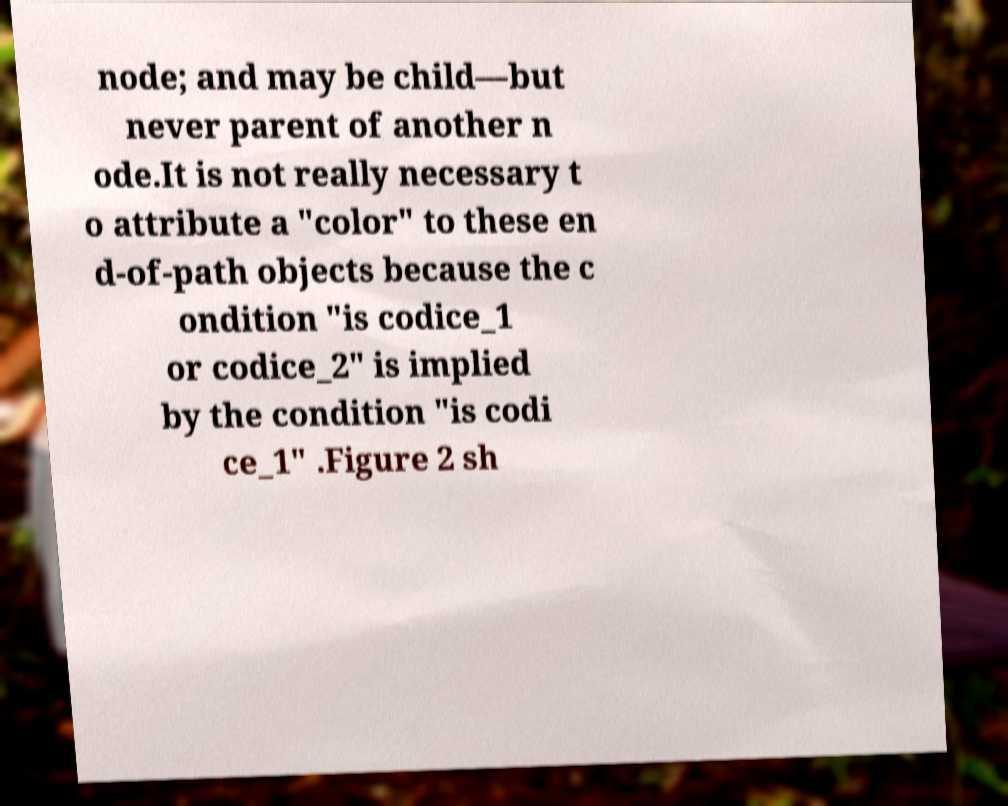Please read and relay the text visible in this image. What does it say? node; and may be child—but never parent of another n ode.It is not really necessary t o attribute a "color" to these en d-of-path objects because the c ondition "is codice_1 or codice_2" is implied by the condition "is codi ce_1" .Figure 2 sh 